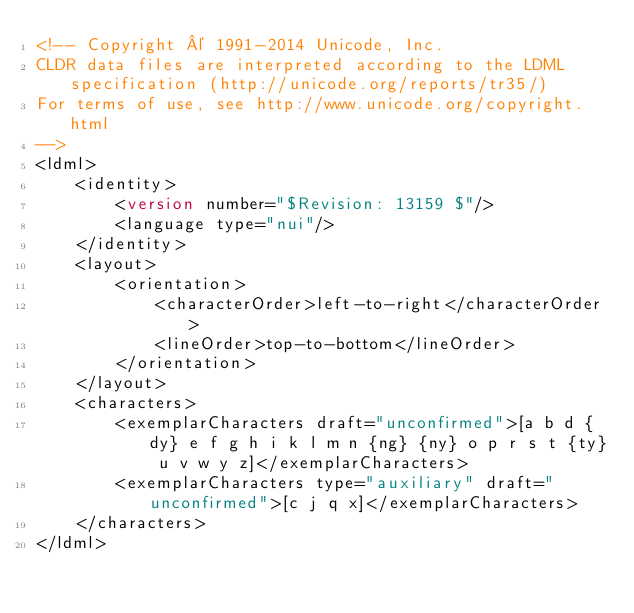Convert code to text. <code><loc_0><loc_0><loc_500><loc_500><_XML_><!-- Copyright © 1991-2014 Unicode, Inc.
CLDR data files are interpreted according to the LDML specification (http://unicode.org/reports/tr35/)
For terms of use, see http://www.unicode.org/copyright.html
-->
<ldml>
	<identity>
		<version number="$Revision: 13159 $"/>
		<language type="nui"/>
	</identity>
	<layout>
		<orientation>
			<characterOrder>left-to-right</characterOrder>
			<lineOrder>top-to-bottom</lineOrder>
		</orientation>
	</layout>
	<characters>
		<exemplarCharacters draft="unconfirmed">[a b d {dy} e f g h i k l m n {ng} {ny} o p r s t {ty} u v w y z]</exemplarCharacters>
		<exemplarCharacters type="auxiliary" draft="unconfirmed">[c j q x]</exemplarCharacters>
	</characters>
</ldml>
</code> 